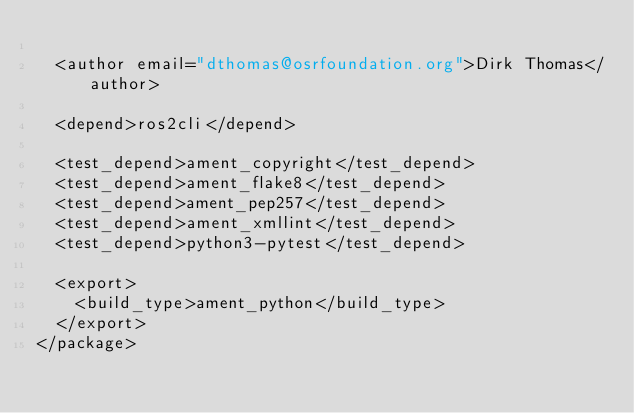<code> <loc_0><loc_0><loc_500><loc_500><_XML_>
  <author email="dthomas@osrfoundation.org">Dirk Thomas</author>

  <depend>ros2cli</depend>

  <test_depend>ament_copyright</test_depend>
  <test_depend>ament_flake8</test_depend>
  <test_depend>ament_pep257</test_depend>
  <test_depend>ament_xmllint</test_depend>
  <test_depend>python3-pytest</test_depend>

  <export>
    <build_type>ament_python</build_type>
  </export>
</package>
</code> 